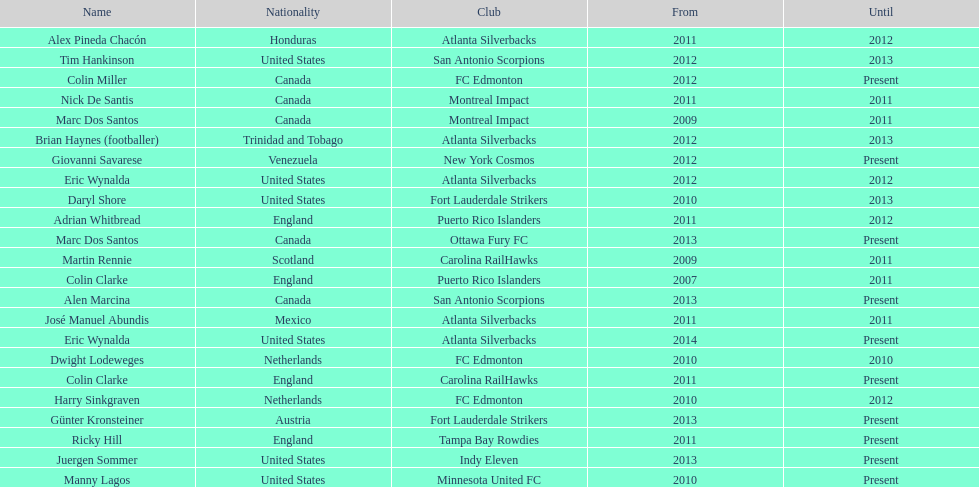Who is the last to coach the san antonio scorpions? Alen Marcina. 